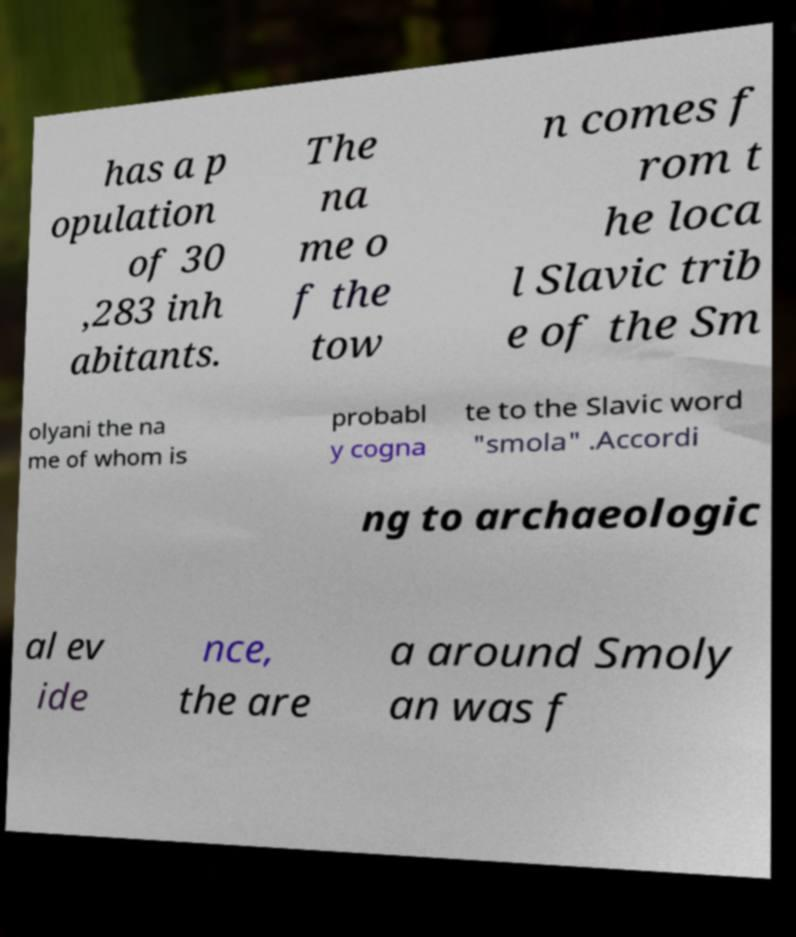There's text embedded in this image that I need extracted. Can you transcribe it verbatim? has a p opulation of 30 ,283 inh abitants. The na me o f the tow n comes f rom t he loca l Slavic trib e of the Sm olyani the na me of whom is probabl y cogna te to the Slavic word "smola" .Accordi ng to archaeologic al ev ide nce, the are a around Smoly an was f 